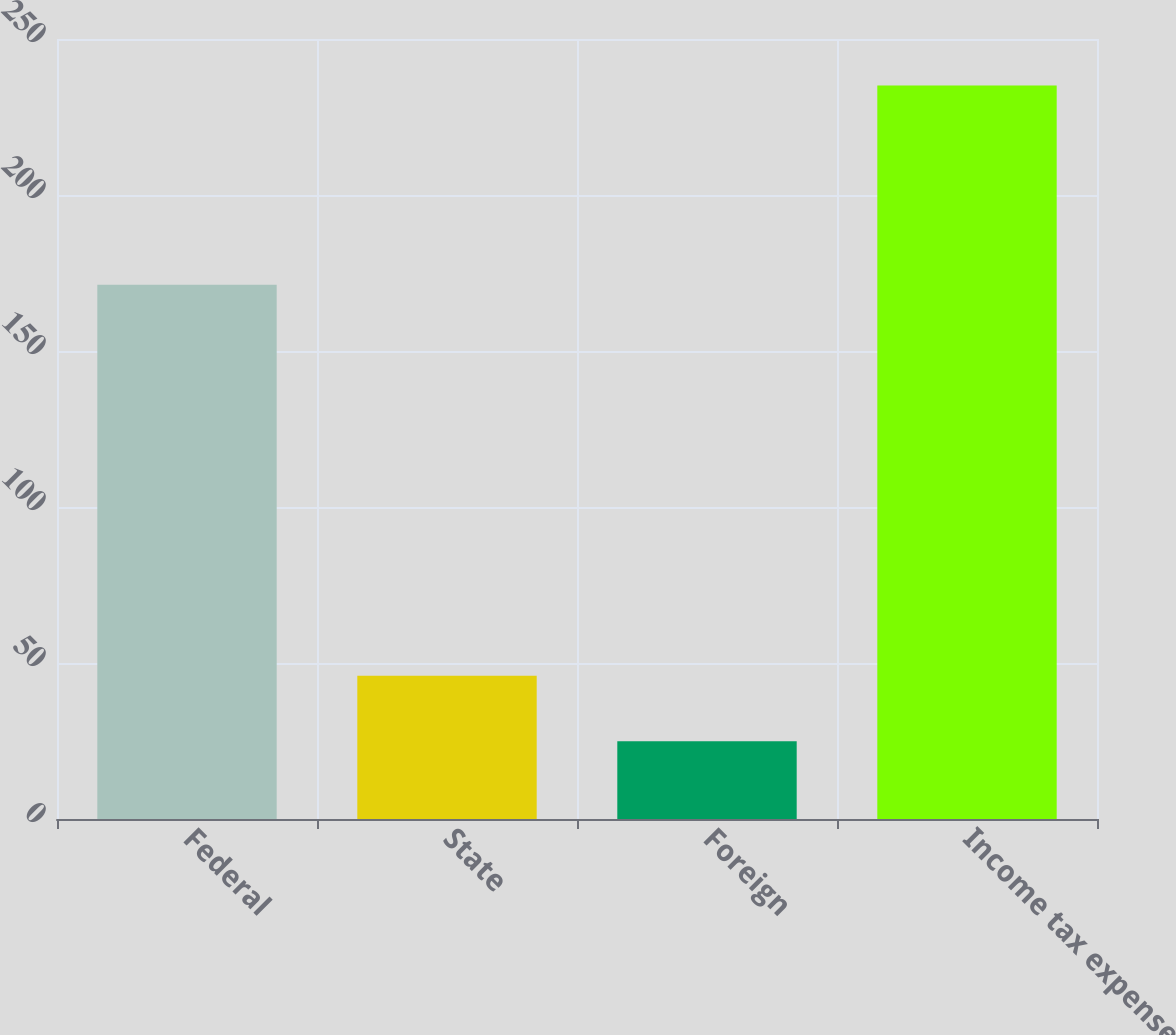Convert chart to OTSL. <chart><loc_0><loc_0><loc_500><loc_500><bar_chart><fcel>Federal<fcel>State<fcel>Foreign<fcel>Income tax expense<nl><fcel>171.2<fcel>45.92<fcel>24.9<fcel>235.1<nl></chart> 